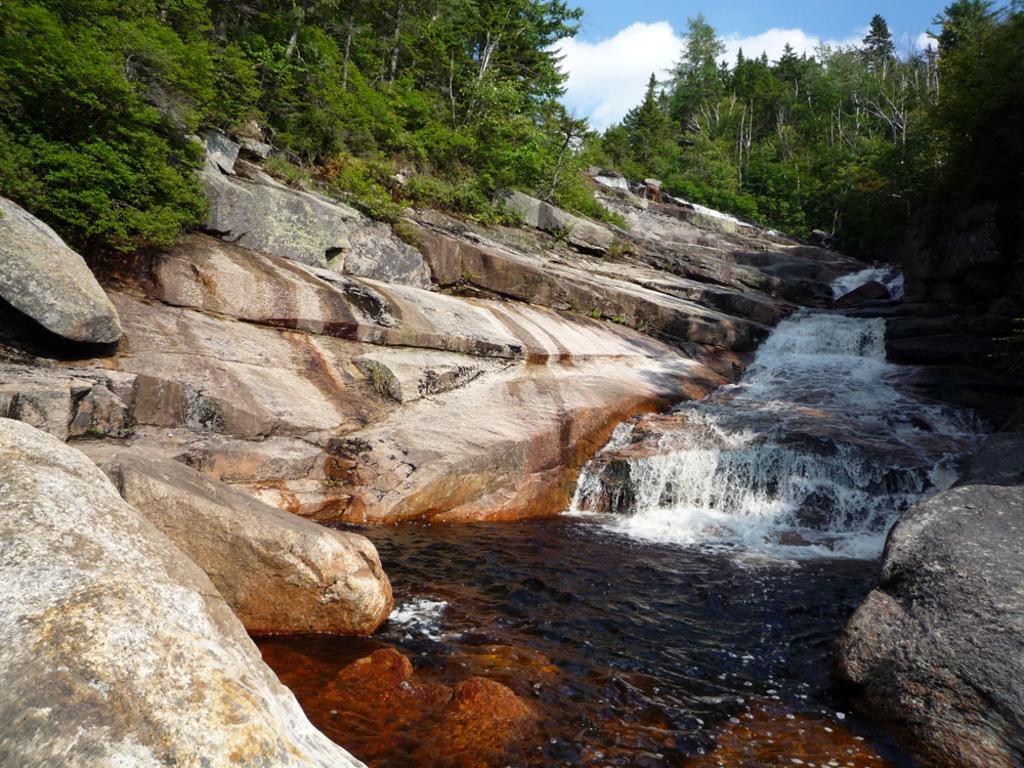Please provide a concise description of this image. In this picture we can see the rocks, waterfalls, trees. At the top of the image we can see the clouds are present in the sky. 